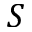<formula> <loc_0><loc_0><loc_500><loc_500>S</formula> 